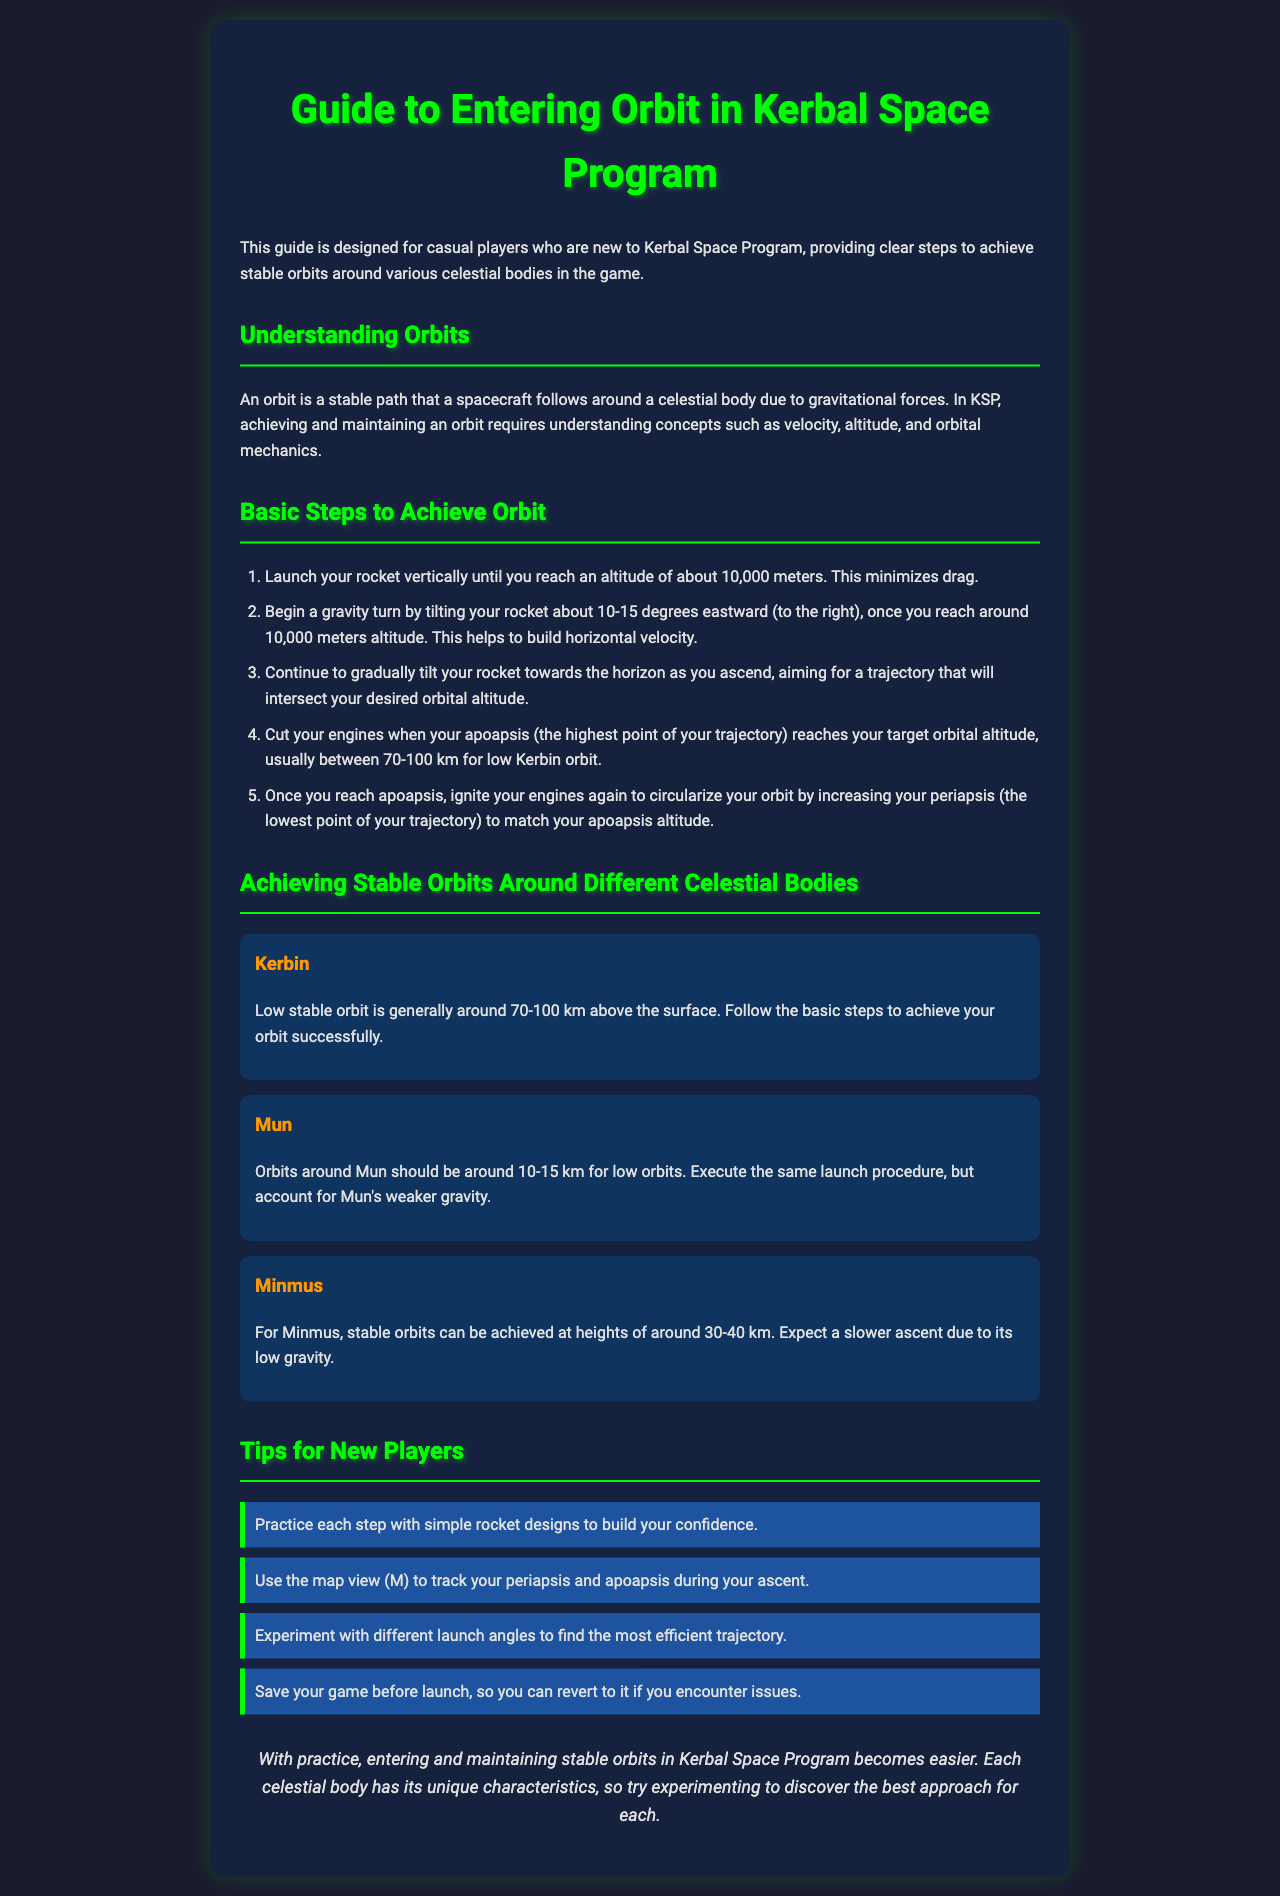What is the altitude for low stable orbit around Kerbin? The document specifies that a low stable orbit around Kerbin is generally around 70-100 km above the surface.
Answer: 70-100 km What should you do when your apoapsis reaches the target orbital altitude? The guide states that you should cut your engines when your apoapsis reaches your target orbital altitude.
Answer: Cut engines What is a recommended altitude for orbits around Mun? The document mentions that orbits around Mun should be around 10-15 km for low orbits.
Answer: 10-15 km Which celestial body has stable orbits at heights of 30-40 km? The guide indicates that Minmus has stable orbits at heights of around 30-40 km.
Answer: Minmus What action improves horizontal velocity after reaching 10,000 meters? The document states that you should begin a gravity turn by tilting your rocket about 10-15 degrees eastward to improve horizontal velocity.
Answer: Gravity turn What is one tip provided for new players? The document lists several tips, one of which is to practice each step with simple rocket designs to build confidence.
Answer: Practice with simple designs What is the main purpose of this guide? The guide is designed to provide clear steps to achieve stable orbits for new players.
Answer: Clear steps to achieve stable orbits What key feature can help you track periapsis and apoapsis during ascent? The document suggests using the map view (M) to track your periapsis and apoapsis.
Answer: Map view (M) How should you prepare before launching your rocket? The document advises saving your game before launch to revert if issues occur.
Answer: Save your game 